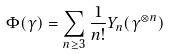Convert formula to latex. <formula><loc_0><loc_0><loc_500><loc_500>\Phi ( \gamma ) = \sum _ { n \geq 3 } \frac { 1 } { n ! } Y _ { n } ( \gamma ^ { \otimes n } )</formula> 